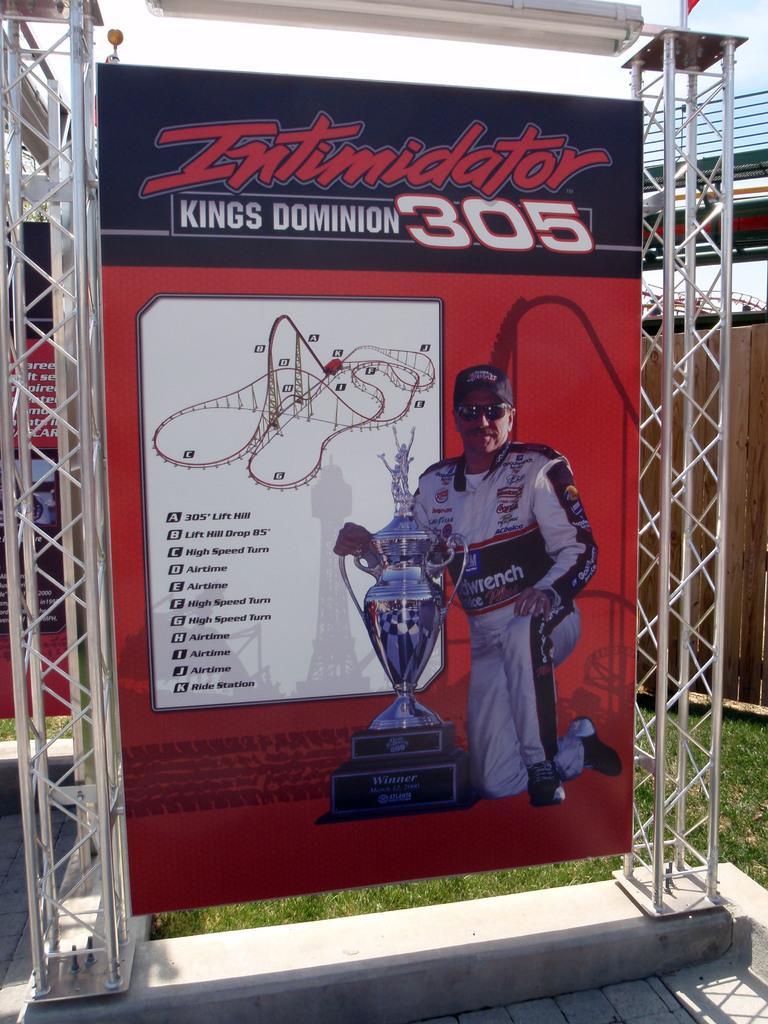<image>
Render a clear and concise summary of the photo. A poster with a man holding a trophy and the word Intimidator at the top. 